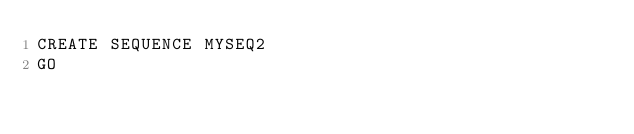Convert code to text. <code><loc_0><loc_0><loc_500><loc_500><_SQL_>CREATE SEQUENCE MYSEQ2
GO
</code> 